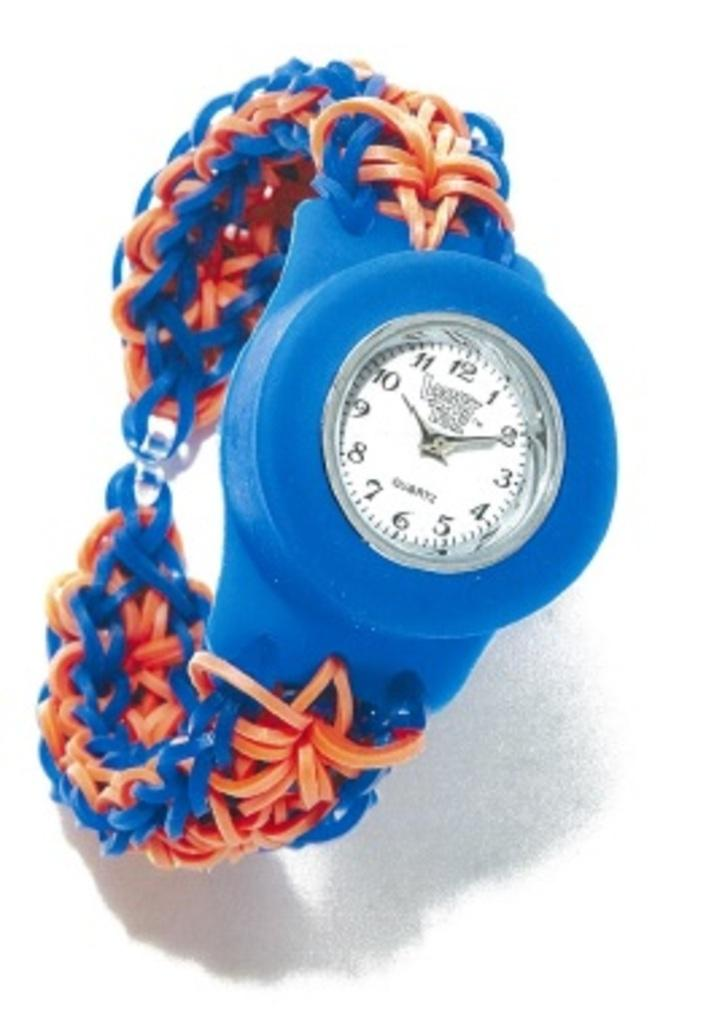<image>
Write a terse but informative summary of the picture. A blue and orange watch says "QUARTZ" on the face. 